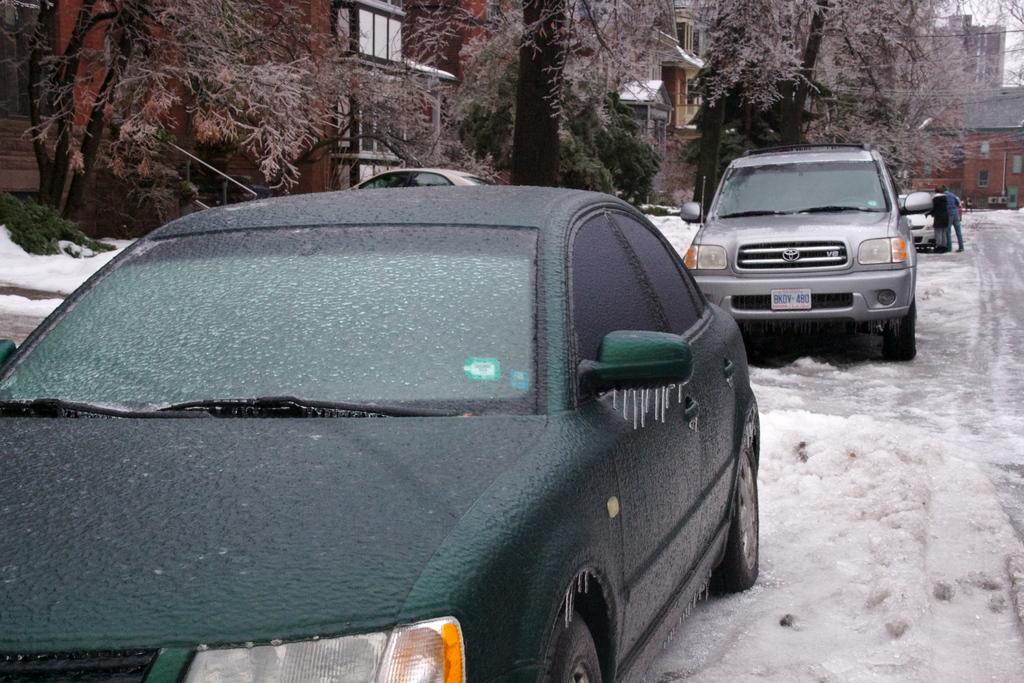What type of vehicles can be seen in the image? There are cars in the image. What is the condition of the ice in the image? The image shows ice. What can be seen at the top of the image? There are trees and buildings at the top of the image. Where are the persons located in the image? The persons are on the right side of the image. What type of comb is being used by the fireman in the image? There is no fireman or comb present in the image. 